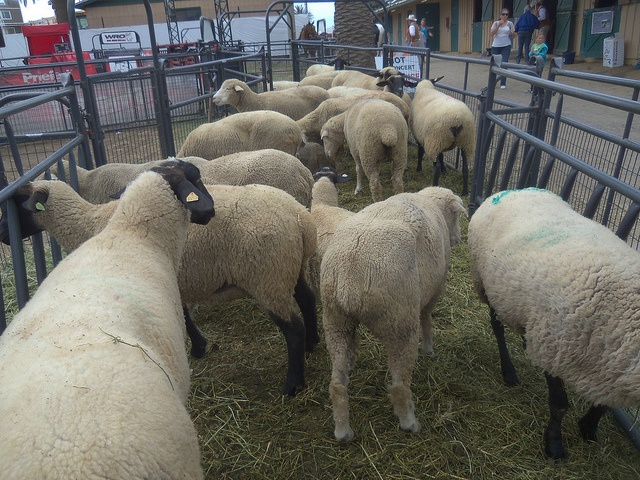Describe the objects in this image and their specific colors. I can see sheep in lightblue, darkgray, lightgray, and gray tones, sheep in lightblue, gray, darkgray, and black tones, sheep in lightblue, gray, darkgray, and black tones, sheep in lightblue, gray, black, and darkgray tones, and sheep in lightblue, gray, darkgray, and black tones in this image. 